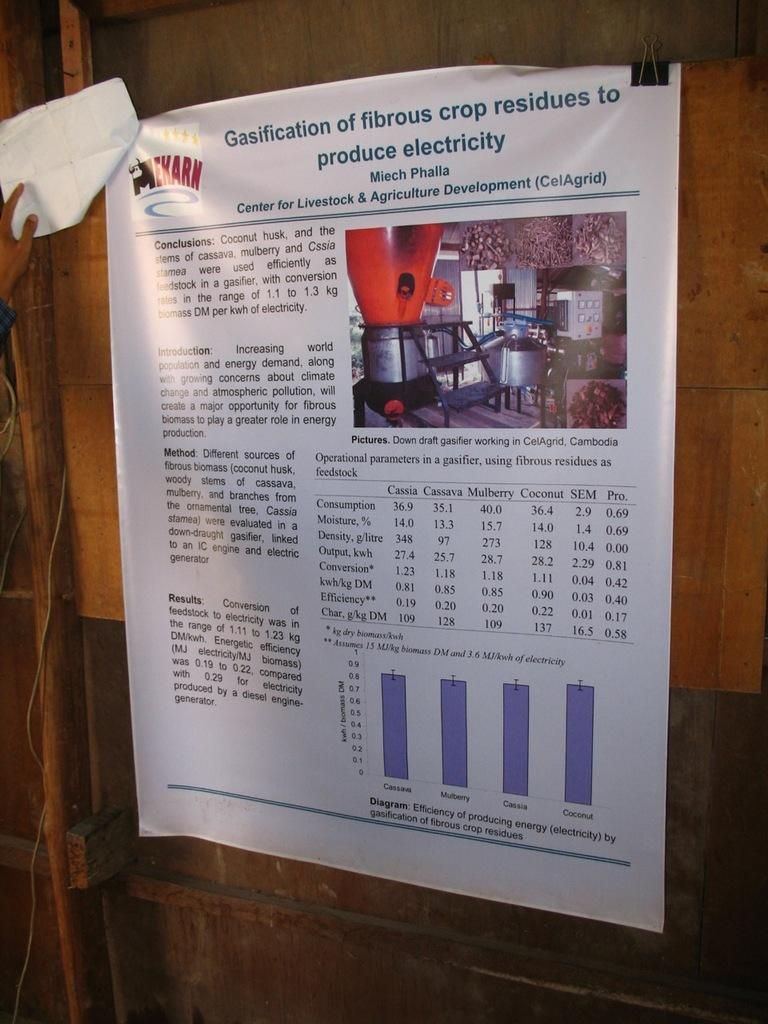<image>
Share a concise interpretation of the image provided. The article on the wall is from the Centre for Livestock and Agriculture Development. 